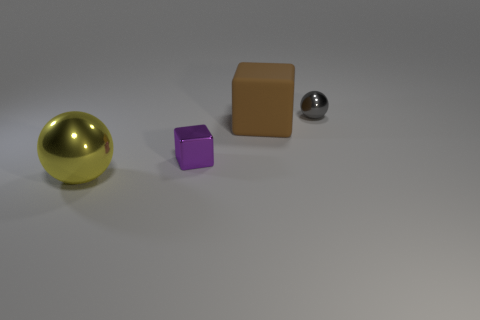How many other things are there of the same shape as the tiny purple object?
Keep it short and to the point. 1. Do the yellow thing and the brown block have the same size?
Your answer should be compact. Yes. Are there any metal things?
Give a very brief answer. Yes. Is there any other thing that has the same material as the large cube?
Offer a terse response. No. Are there any small gray balls made of the same material as the big sphere?
Make the answer very short. Yes. There is a object that is the same size as the brown rubber cube; what is its material?
Your answer should be very brief. Metal. What number of other small purple objects are the same shape as the matte thing?
Provide a succinct answer. 1. There is a gray thing that is made of the same material as the purple block; what size is it?
Your response must be concise. Small. There is a object that is to the right of the yellow metal thing and to the left of the big brown object; what material is it made of?
Give a very brief answer. Metal. How many other things have the same size as the yellow thing?
Make the answer very short. 1. 